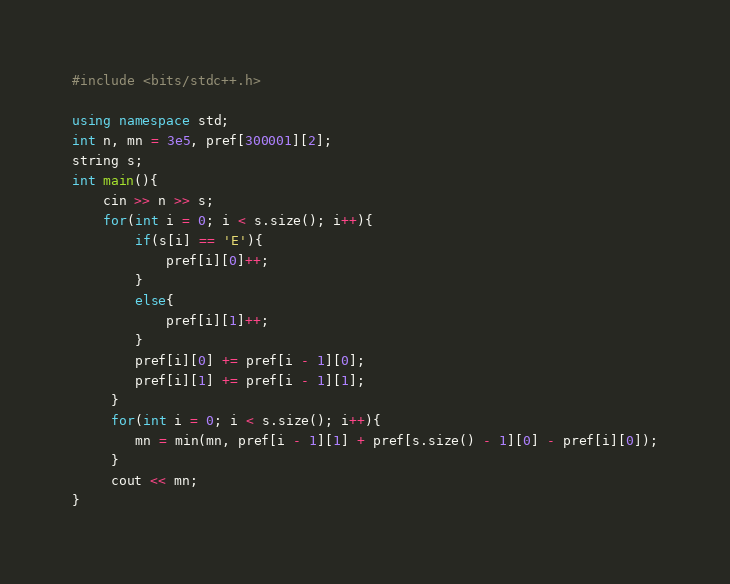<code> <loc_0><loc_0><loc_500><loc_500><_C++_>#include <bits/stdc++.h>

using namespace std;
int n, mn = 3e5, pref[300001][2];
string s;
int main(){
    cin >> n >> s;
    for(int i = 0; i < s.size(); i++){
        if(s[i] == 'E'){
            pref[i][0]++;
        }
        else{
            pref[i][1]++;
        }
        pref[i][0] += pref[i - 1][0];
        pref[i][1] += pref[i - 1][1];
     }
     for(int i = 0; i < s.size(); i++){
        mn = min(mn, pref[i - 1][1] + pref[s.size() - 1][0] - pref[i][0]);
     }
     cout << mn;
}
</code> 